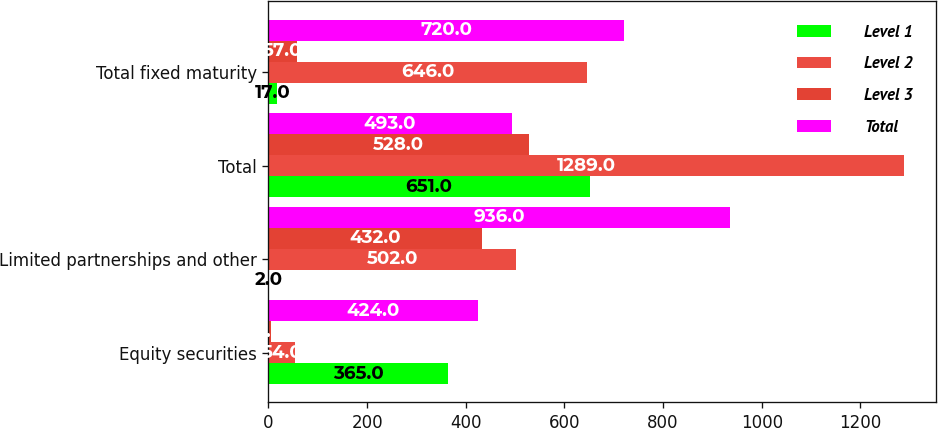<chart> <loc_0><loc_0><loc_500><loc_500><stacked_bar_chart><ecel><fcel>Equity securities<fcel>Limited partnerships and other<fcel>Total<fcel>Total fixed maturity<nl><fcel>Level 1<fcel>365<fcel>2<fcel>651<fcel>17<nl><fcel>Level 2<fcel>54<fcel>502<fcel>1289<fcel>646<nl><fcel>Level 3<fcel>5<fcel>432<fcel>528<fcel>57<nl><fcel>Total<fcel>424<fcel>936<fcel>493<fcel>720<nl></chart> 